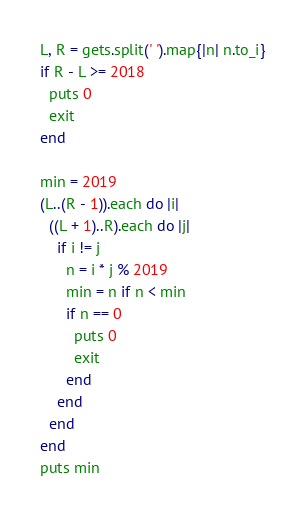Convert code to text. <code><loc_0><loc_0><loc_500><loc_500><_Ruby_>L, R = gets.split(' ').map{|n| n.to_i}
if R - L >= 2018
  puts 0
  exit
end

min = 2019
(L..(R - 1)).each do |i|
  ((L + 1)..R).each do |j|
    if i != j
      n = i * j % 2019
      min = n if n < min
      if n == 0
        puts 0
        exit
      end
    end
  end
end
puts min</code> 